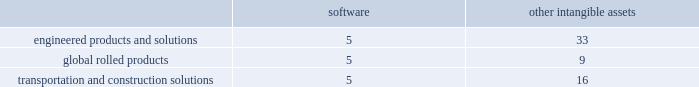Discounted cash flow model ( dcf ) to estimate the current fair value of its reporting units when testing for impairment , as management believes forecasted cash flows are the best indicator of such fair value .
A number of significant assumptions and estimates are involved in the application of the dcf model to forecast operating cash flows , including sales growth ( volumes and pricing ) , production costs , capital spending , and discount rate .
Most of these assumptions vary significantly among the reporting units .
Cash flow forecasts are generally based on approved business unit operating plans for the early years and historical relationships in later years .
The wacc rate for the individual reporting units is estimated with the assistance of valuation experts .
Arconic would recognize an impairment charge for the amount by which the carrying amount exceeds the reporting unit 2019s fair value without exceeding the total amount of goodwill allocated to that reporting unit .
In connection with the interim impairment evaluation of long-lived assets for the disks operations ( an asset group within the aen business unit ) in the second quarter of 2018 , which resulted from a decline in forecasted financial performance for the business in connection with its updated three-year strategic plan , the company also performed an interim impairment evaluation of goodwill for the aen reporting unit .
The estimated fair value of the reporting unit was substantially in excess of the carrying value ; thus , there was no impairment of goodwill .
Goodwill impairment tests in 2017 and 2016 indicated that goodwill was not impaired for any of the company 2019s reporting units , except for the arconic forgings and extrusions ( afe ) business whose estimated fair value was lower than its carrying value .
As such , arconic recorded an impairment for the full amount of goodwill in the afe reporting unit of $ 719 .
The decrease in the afe fair value was primarily due to unfavorable performance that was impacting operating margins and a higher discount rate due to an increase in the risk-free rate of return , while the carrying value increased compared to prior year .
Other intangible assets .
Intangible assets with indefinite useful lives are not amortized while intangible assets with finite useful lives are amortized generally on a straight-line basis over the periods benefited .
The table details the weighted- average useful lives of software and other intangible assets by reporting segment ( numbers in years ) : .
Revenue recognition .
The company's contracts with customers are comprised of acknowledged purchase orders incorporating the company 2019s standard terms and conditions , or for larger customers , may also generally include terms under negotiated multi-year agreements .
These contracts with customers typically consist of the manufacture of products which represent single performance obligations that are satisfied upon transfer of control of the product to the customer .
The company produces fastening systems ; seamless rolled rings ; investment castings , including airfoils and forged jet engine components ; extruded , machined and formed aircraft parts ; aluminum sheet and plate ; integrated aluminum structural systems ; architectural extrusions ; and forged aluminum commercial vehicle wheels .
Transfer of control is assessed based on alternative use of the products we produce and our enforceable right to payment for performance to date under the contract terms .
Transfer of control and revenue recognition generally occur upon shipment or delivery of the product , which is when title , ownership and risk of loss pass to the customer and is based on the applicable shipping terms .
The shipping terms vary across all businesses and depend on the product , the country of origin , and the type of transportation ( truck , train , or vessel ) .
An invoice for payment is issued at time of shipment .
The company 2019s objective is to have net 30-day terms .
Our business units set commercial terms on which arconic sells products to its customers .
These terms are influenced by industry custom , market conditions , product line ( specialty versus commodity products ) , and other considerations .
In certain circumstances , arconic receives advanced payments from its customers for product to be delivered in future periods .
These advanced payments are recorded as deferred revenue until the product is delivered and title and risk of loss have passed to the customer in accordance with the terms of the contract .
Deferred revenue is included in other current liabilities and other noncurrent liabilities and deferred credits on the accompanying consolidated balance sheet .
Environmental matters .
Expenditures for current operations are expensed or capitalized , as appropriate .
Expenditures relating to existing conditions caused by past operations , which will not contribute to future revenues , are expensed .
Liabilities are recorded when remediation costs are probable and can be reasonably estimated .
The liability may include costs such as site investigations , consultant fees , feasibility studies , outside contractors , and monitoring expenses .
Estimates are generally not discounted or reduced by potential claims for recovery .
Claims for recovery are recognized when probable and as agreements are reached with third parties .
The estimates also include costs related to other potentially responsible parties to the extent that arconic has reason to believe such parties will not fully pay their proportionate share .
The liability is continuously reviewed and adjusted to reflect current remediation progress , prospective estimates of required activity , and other factors that may be relevant , including changes in technology or regulations .
Litigation matters .
For asserted claims and assessments , liabilities are recorded when an unfavorable outcome of a matter is .
What is the difference between the weighted average useful lives of software and other intangible assets in the transportation and construction solutions segment , in years? 
Rationale: it is the difference between the number of years .
Computations: (16 - 5)
Answer: 11.0. 